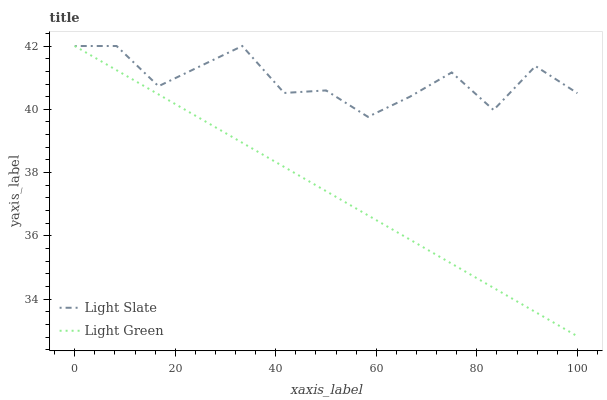Does Light Green have the minimum area under the curve?
Answer yes or no. Yes. Does Light Slate have the maximum area under the curve?
Answer yes or no. Yes. Does Light Green have the maximum area under the curve?
Answer yes or no. No. Is Light Green the smoothest?
Answer yes or no. Yes. Is Light Slate the roughest?
Answer yes or no. Yes. Is Light Green the roughest?
Answer yes or no. No. Does Light Green have the highest value?
Answer yes or no. Yes. Does Light Green intersect Light Slate?
Answer yes or no. Yes. Is Light Green less than Light Slate?
Answer yes or no. No. Is Light Green greater than Light Slate?
Answer yes or no. No. 